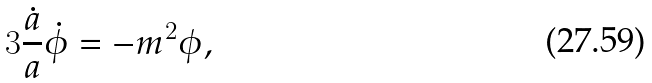Convert formula to latex. <formula><loc_0><loc_0><loc_500><loc_500>3 \frac { \dot { a } } { a } \dot { \phi } = - m ^ { 2 } \phi ,</formula> 